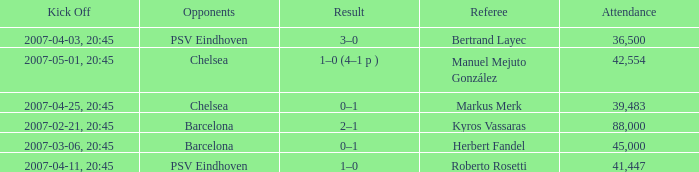WHAT WAS THE SCORE OF THE GAME WITH A 2007-03-06, 20:45 KICKOFF? 0–1. 